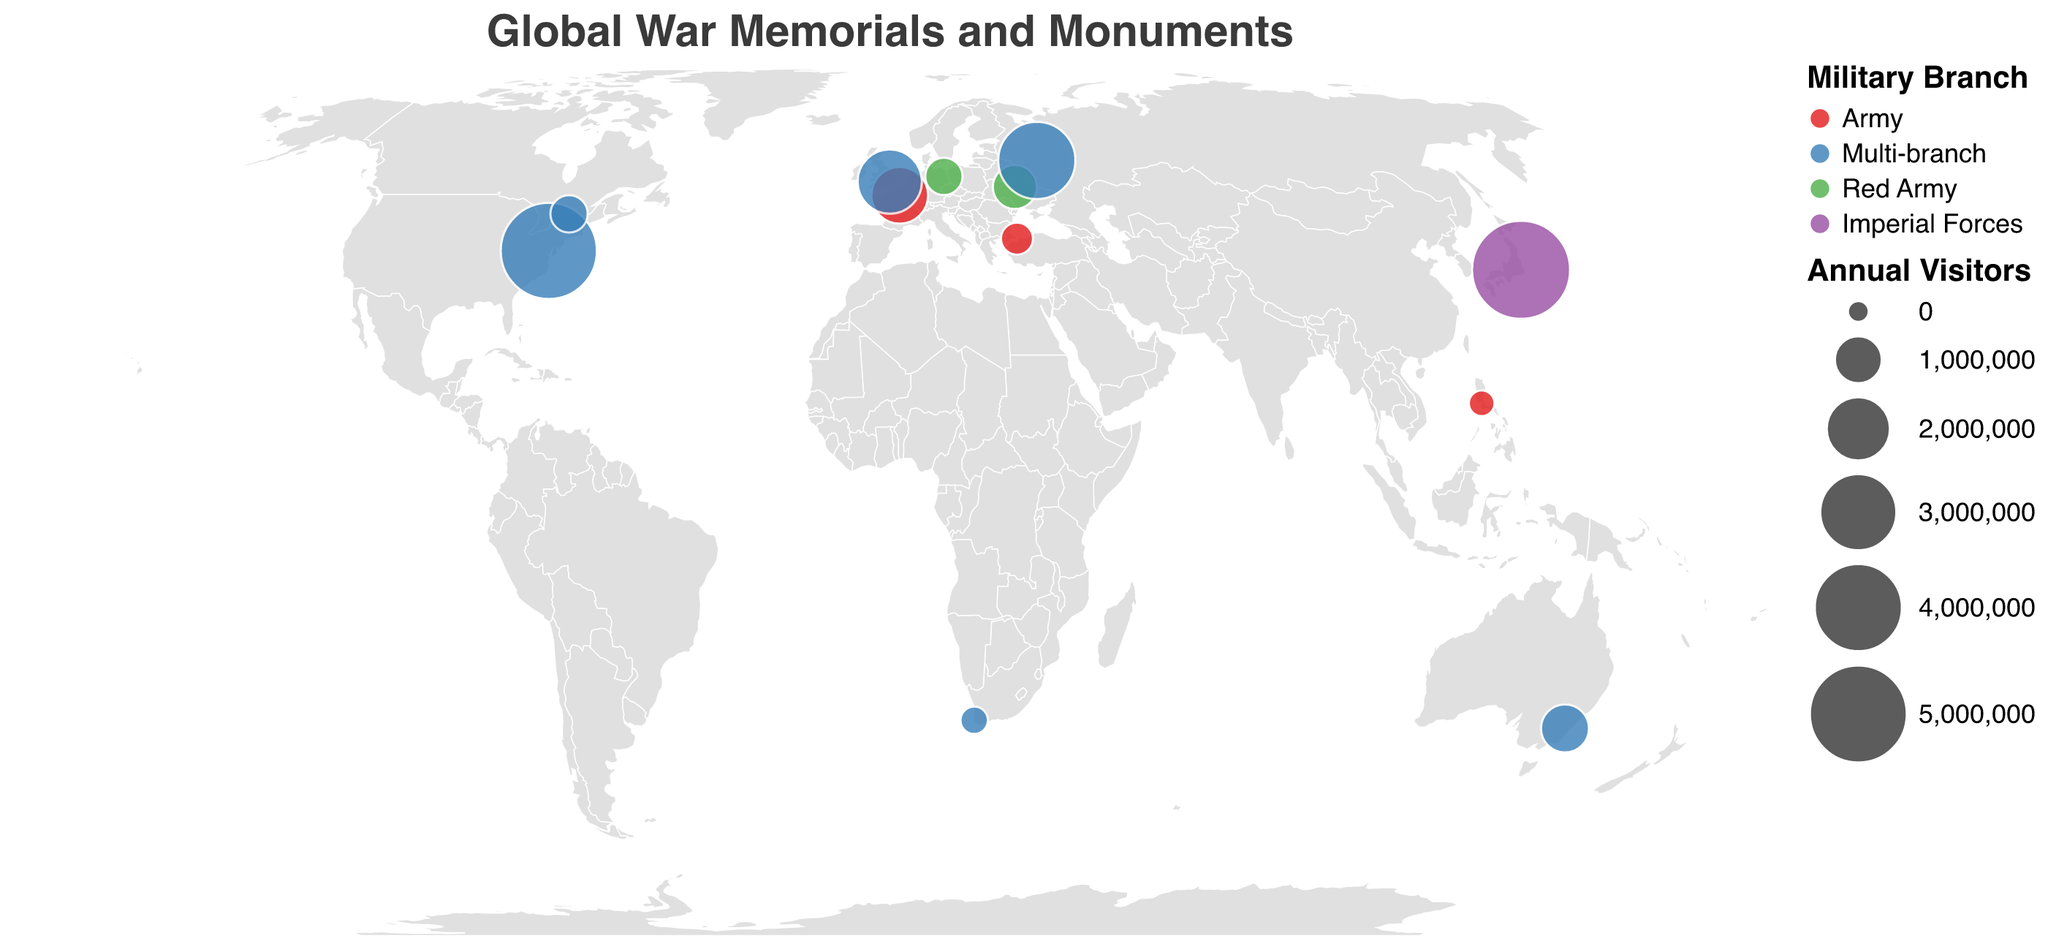Which war memorial has the highest number of annual visitors? By looking at the sizes of the circles on the plot, the Yasukuni Shrine in Japan has the largest circle, indicating it has the highest number of annual visitors.
Answer: Yasukuni Shrine Which country hosts the war memorial with the fewest annual visitors? By examining the tooltip for each circle, the Manila American Cemetery in the Philippines has the smallest number of annual visitors at 100,000.
Answer: Philippines How many war memorials are dedicated to the Army branch? Look for circles colored in red (representing the Army branch). Counting these circles, we see there are 4: Arc de Triomphe (France), Manila American Cemetery (Philippines), Martyrs' Memorial (Turkey), and Yasukuni Shrine (Japan).
Answer: 4 What is the total number of annual visitors for all the multi-branch war memorials combined? Identify the circles representing multi-branch memorials (colored in blue), and sum their visitor counts: National World War II Memorial (USA): 4,800,000, Cenotaph (UK): 2,000,000, Australian War Memorial (Australia): 1,000,000, Cape Town Cenotaph (South Africa): 150,000, National War Memorial (Canada): 500,000, Tomb of the Unknown Soldier (Russia): 3,000,000. Add these values to get the total.
Answer: 11,450,000 Which war memorial in Europe has the highest number of visitors? Locate the circles within Europe and identify which one has the largest size. The Tomb of the Unknown Soldier in Russia indicates 3,000,000 visitors, which is the highest among European memorials.
Answer: Tomb of the Unknown Soldier What are the colors used to represent each military branch? By examining the legend provided in the figure: Army is red, Multi-branch is blue, Red Army is green, and Imperial Forces is purple.
Answer: Red, blue, green, purple Compare the number of annual visitors between the Arc de Triomphe in France and the Cenotaph in the UK. Which one has more visitors and by how much? Consult their respective visitor counts from the tooltips. Arc de Triomphe has 1,500,000 visitors, and the Cenotaph has 2,000,000 visitors. Calculate the difference: 2,000,000 - 1,500,000 = 500,000. The Cenotaph has more visitors by 500,000.
Answer: Cenotaph by 500,000 What is the average number of annual visitors for the Red Army memorials? Identify Red Army memorials (colored in green) and note their annual visitors: Soviet War Memorial (Germany): 500,000, and Motherland Monument (Ukraine): 800,000. Calculate the average: (500,000 + 800,000) / 2 = 650,000.
Answer: 650,000 What is the location (latitude and longitude) of the Cape Town Cenotaph? Refer to the tooltip for the Cape Town Cenotaph: Latitude: -33.9249, Longitude: 18.4241.
Answer: Latitude: -33.9249, Longitude: 18.4241 